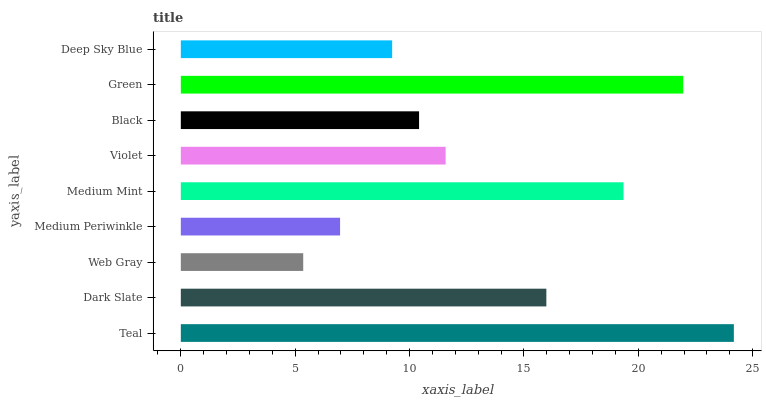Is Web Gray the minimum?
Answer yes or no. Yes. Is Teal the maximum?
Answer yes or no. Yes. Is Dark Slate the minimum?
Answer yes or no. No. Is Dark Slate the maximum?
Answer yes or no. No. Is Teal greater than Dark Slate?
Answer yes or no. Yes. Is Dark Slate less than Teal?
Answer yes or no. Yes. Is Dark Slate greater than Teal?
Answer yes or no. No. Is Teal less than Dark Slate?
Answer yes or no. No. Is Violet the high median?
Answer yes or no. Yes. Is Violet the low median?
Answer yes or no. Yes. Is Green the high median?
Answer yes or no. No. Is Medium Periwinkle the low median?
Answer yes or no. No. 